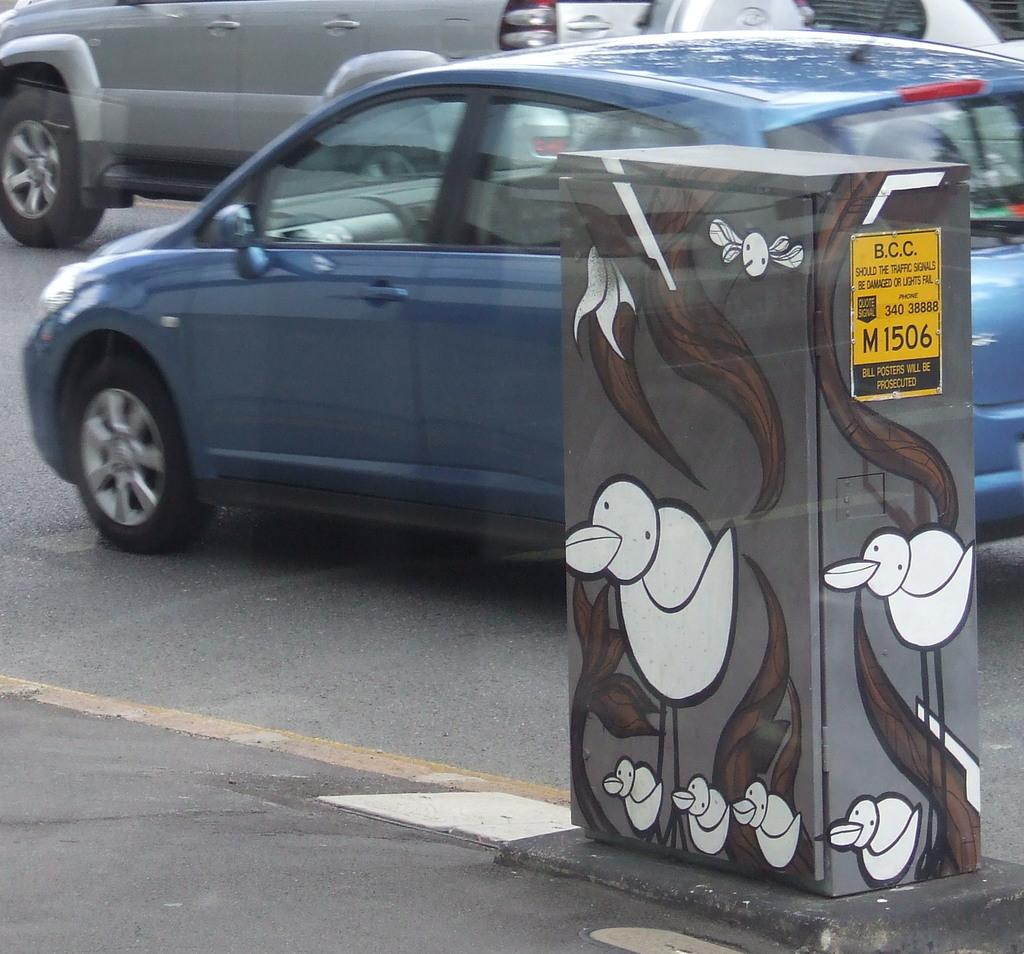What is happening in the image involving vehicles? There are cars traveling on the road in the image. Can you describe any objects in the image besides the cars? Yes, there is a box in the image. What is on the surface of the box? There is a painting on the box. What type of acoustics can be heard from the box in the image? There is no indication of any sound or acoustics coming from the box in the image. What time of day is depicted in the image? The time of day is not mentioned or depicted in the image. 